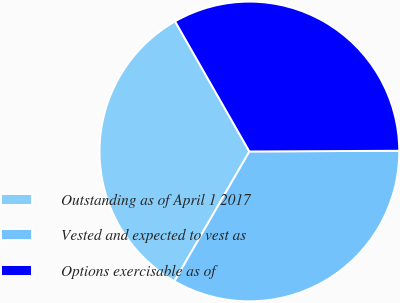Convert chart. <chart><loc_0><loc_0><loc_500><loc_500><pie_chart><fcel>Outstanding as of April 1 2017<fcel>Vested and expected to vest as<fcel>Options exercisable as of<nl><fcel>33.41%<fcel>33.41%<fcel>33.18%<nl></chart> 